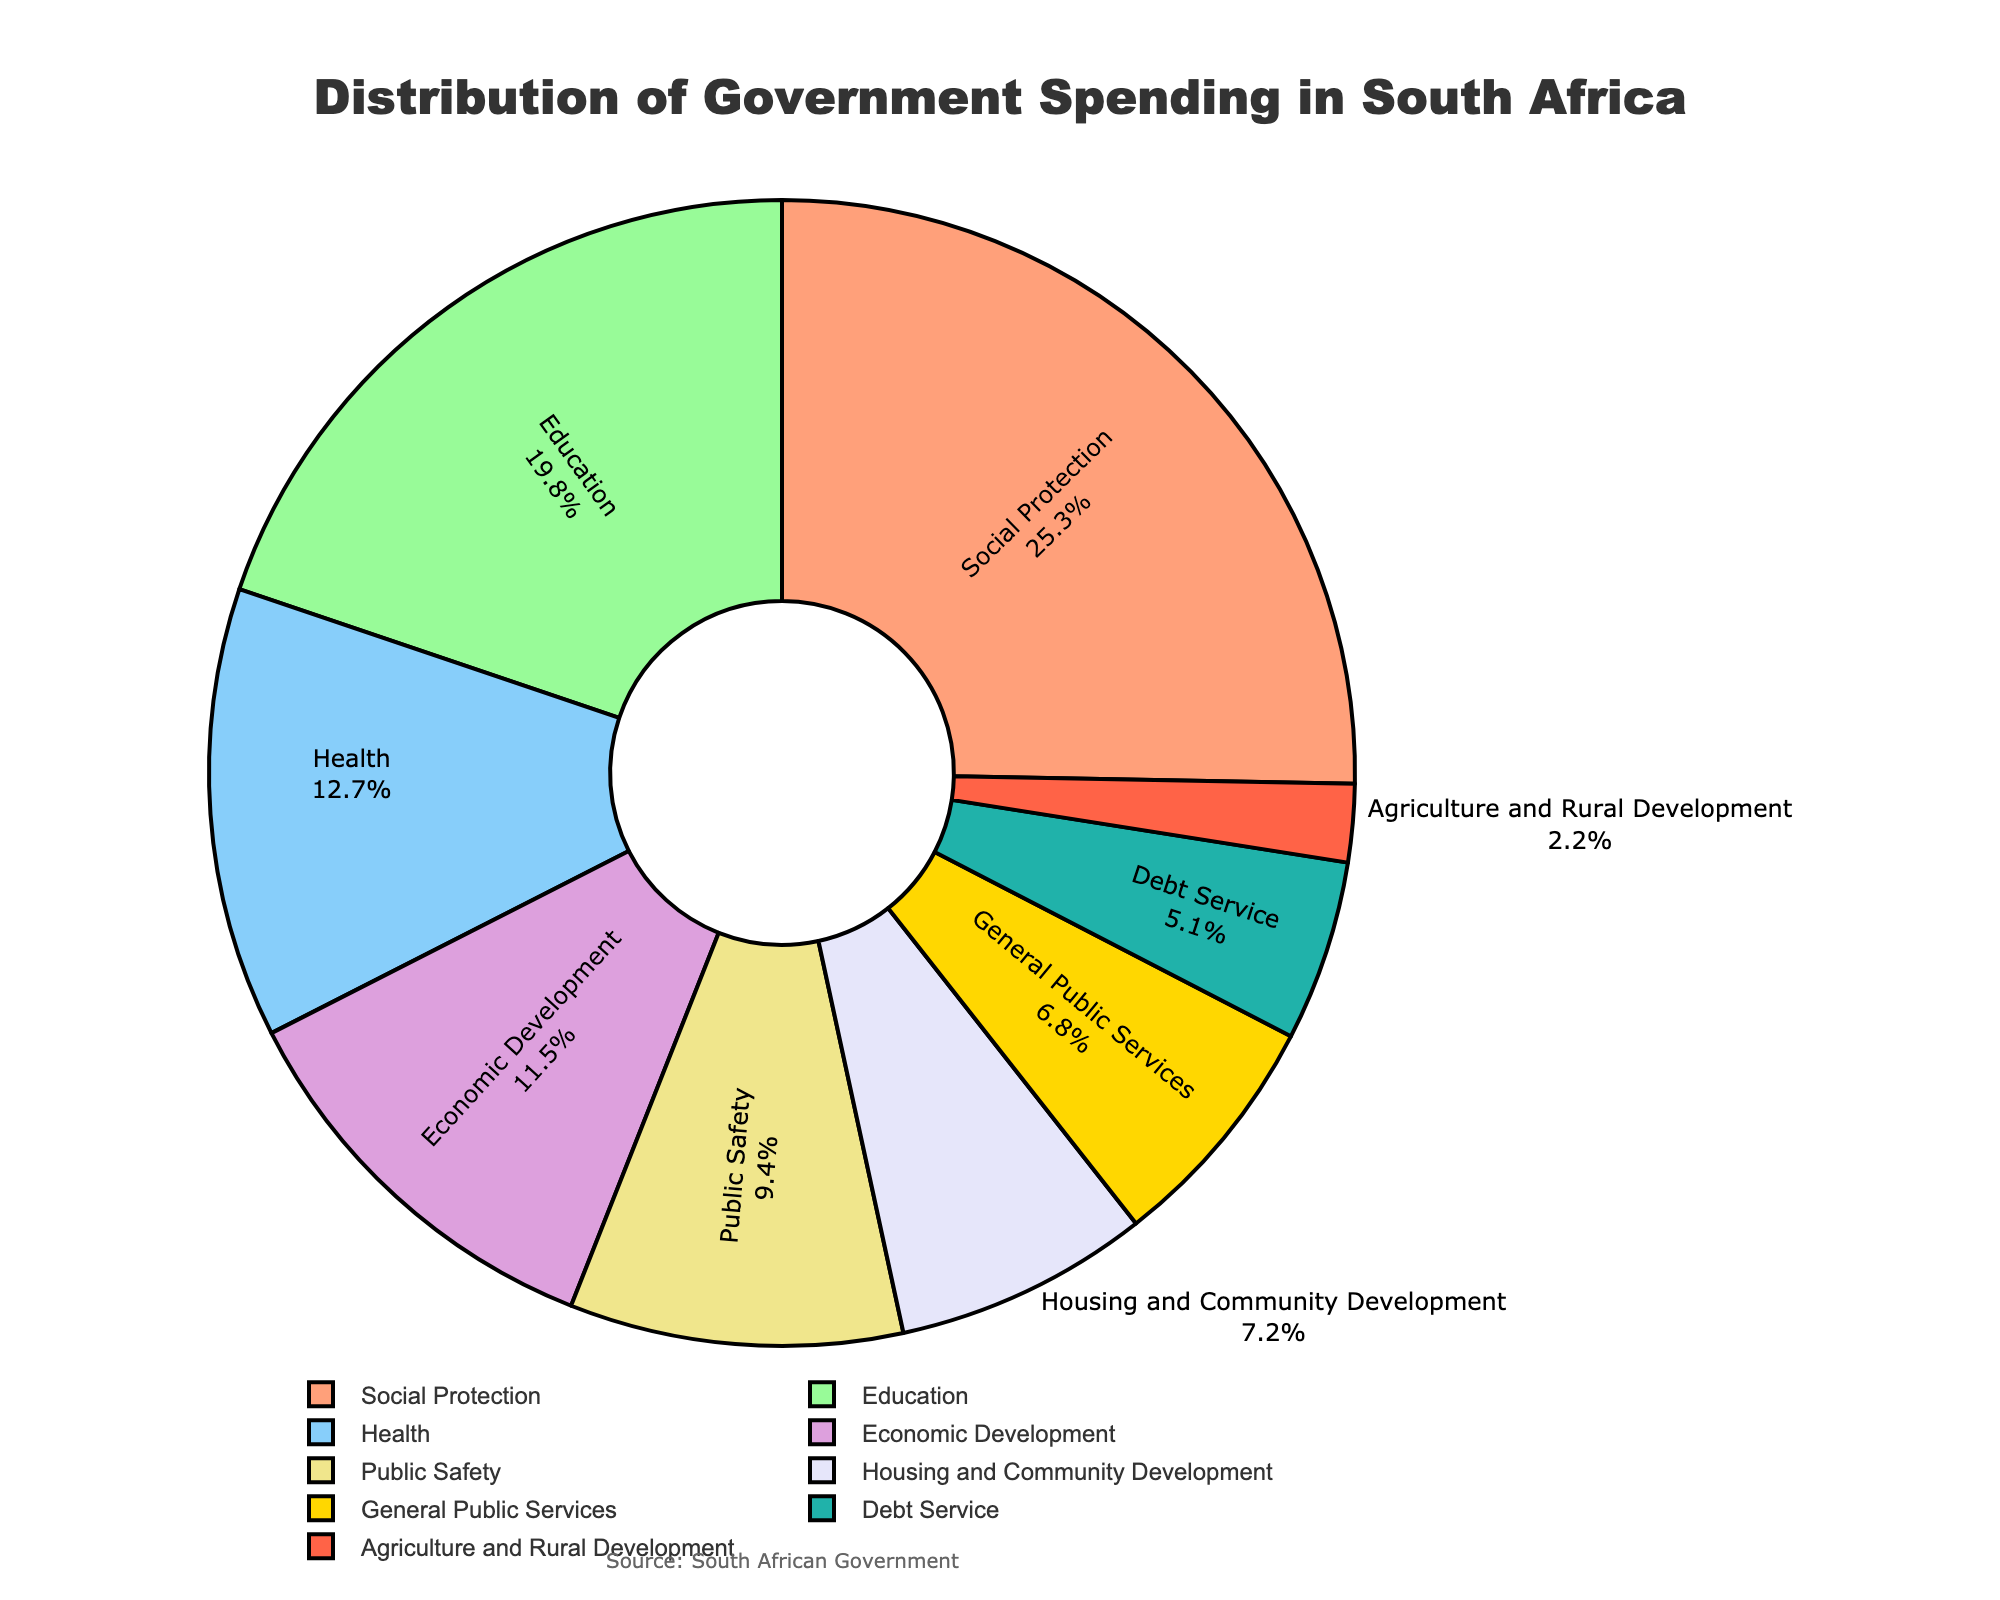What sector receives the largest portion of government spending? The largest portion of the pie chart corresponds to the "Social Protection" sector. This sector takes up 25.3% of the distribution.
Answer: Social Protection Which sector has the smallest allocation of government spending? The smallest portion of the pie chart corresponds to "Agriculture and Rural Development," which receives 2.2% of the distribution.
Answer: Agriculture and Rural Development What's the total percentage of government spending dedicated to Education and Health combined? To find the combined percentage, add the percentage for Education (19.8%) and Health (12.7%): 19.8% + 12.7% = 32.5%.
Answer: 32.5% Is spending on Public Safety greater than spending on Economic Development? The percentage of spending on Public Safety is 9.4%, whereas for Economic Development it's 11.5%. So, spending on Public Safety is not greater.
Answer: No How much more is spent on Social Protection compared to Debt Service? Subtract the percentage of Debt Service (5.1%) from Social Protection (25.3%): 25.3% - 5.1% = 20.2%.
Answer: 20.2% Does Housing and Community Development receive more funding than General Public Services? Housing and Community Development receives 7.2% and General Public Services receives 6.8%. Therefore, yes, Housing and Community Development receives more.
Answer: Yes What's the average percentage of government spending on Health, Economic Development, and Public Safety? First, sum the percentages: Health (12.7%) + Economic Development (11.5%) + Public Safety (9.4%) = 33.6%. Then, divide by the number of sectors (3): 33.6% / 3 = 11.2%.
Answer: 11.2% How does the spending on Education compare to the overall percentage dedicated to Public Safety, Housing, and General Public Services combined? To compare, first sum the percentages for Public Safety (9.4%), Housing and Community Development (7.2%), and General Public Services (6.8%): 9.4% + 7.2% + 6.8% = 23.4%. Education has 19.8%, which is less than the combined total of 23.4%.
Answer: Less What is the combined spending percentage on Social Protection and Housing and Community Development? Add the percentage for Social Protection (25.3%) and Housing and Community Development (7.2%): 25.3% + 7.2% = 32.5%.
Answer: 32.5% What is the contribution of Economic Development relative to Debt Service in terms of percentage points? Subtract the percentage of Debt Service (5.1%) from Economic Development (11.5%): 11.5% - 5.1% = 6.4 percentage points.
Answer: 6.4 